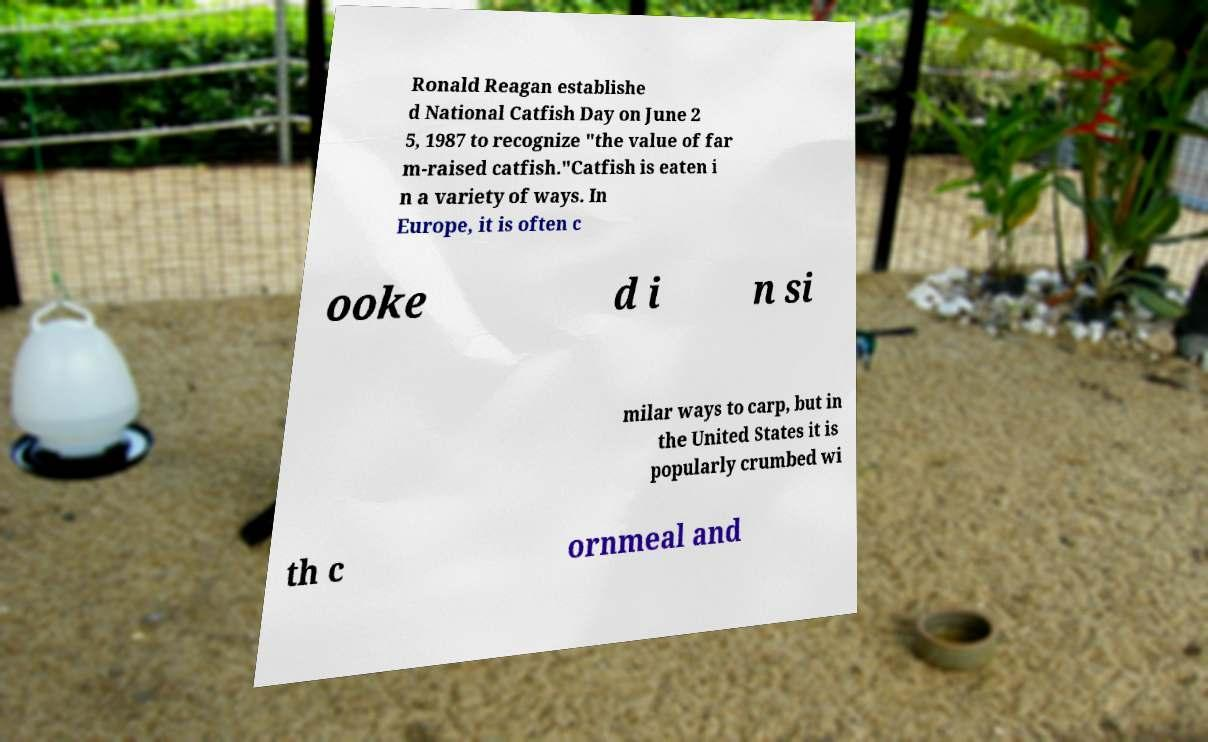For documentation purposes, I need the text within this image transcribed. Could you provide that? Ronald Reagan establishe d National Catfish Day on June 2 5, 1987 to recognize "the value of far m-raised catfish."Catfish is eaten i n a variety of ways. In Europe, it is often c ooke d i n si milar ways to carp, but in the United States it is popularly crumbed wi th c ornmeal and 